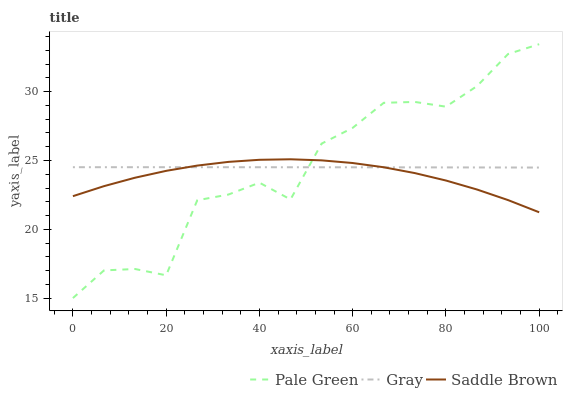Does Saddle Brown have the minimum area under the curve?
Answer yes or no. Yes. Does Pale Green have the maximum area under the curve?
Answer yes or no. Yes. Does Pale Green have the minimum area under the curve?
Answer yes or no. No. Does Saddle Brown have the maximum area under the curve?
Answer yes or no. No. Is Gray the smoothest?
Answer yes or no. Yes. Is Pale Green the roughest?
Answer yes or no. Yes. Is Saddle Brown the smoothest?
Answer yes or no. No. Is Saddle Brown the roughest?
Answer yes or no. No. Does Pale Green have the lowest value?
Answer yes or no. Yes. Does Saddle Brown have the lowest value?
Answer yes or no. No. Does Pale Green have the highest value?
Answer yes or no. Yes. Does Saddle Brown have the highest value?
Answer yes or no. No. Does Saddle Brown intersect Gray?
Answer yes or no. Yes. Is Saddle Brown less than Gray?
Answer yes or no. No. Is Saddle Brown greater than Gray?
Answer yes or no. No. 